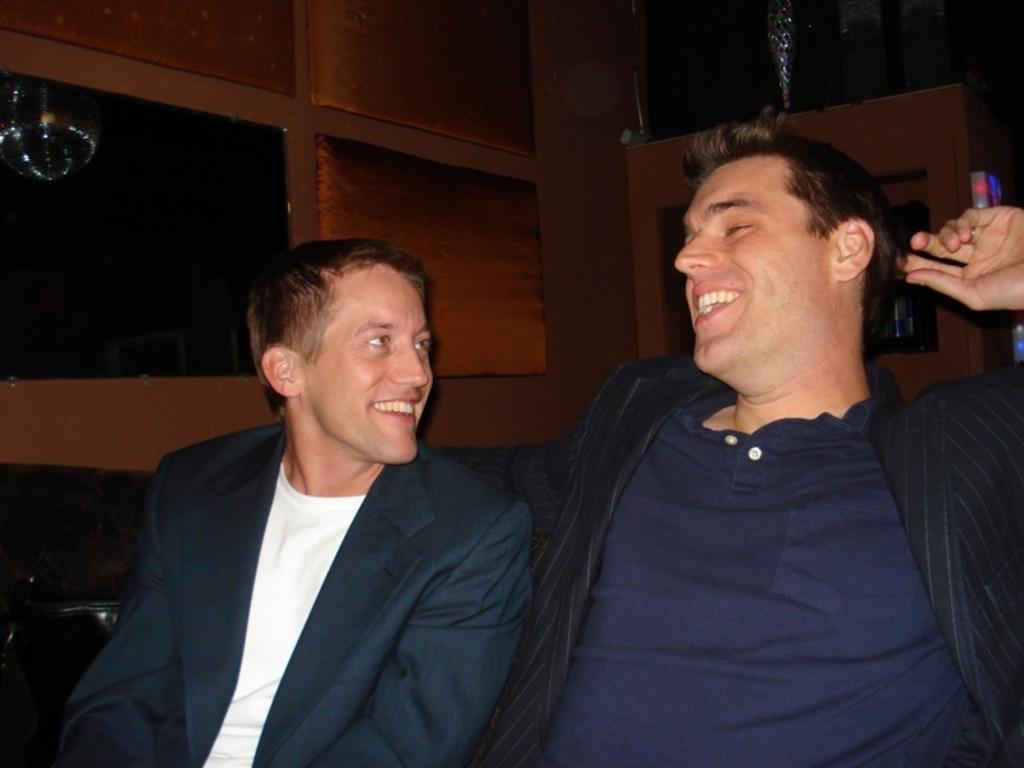How many people are in the image? There are two men in the image. What are the men doing in the image? The men are sitting in the image. What expressions do the men have in the image? The men are smiling in the image. What are the men wearing in the image? The men are wearing coats in the image. What can be seen in the background of the image? There is a wooden wall and other objects visible in the background of the image. What type of care can be seen being provided to the dolls in the image? There are no dolls present in the image, so no care can be provided to them. How many toes can be seen on the men in the image? The image does not show the men's toes, so it is not possible to determine the number of toes visible. 